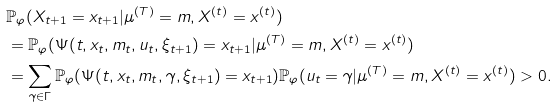Convert formula to latex. <formula><loc_0><loc_0><loc_500><loc_500>& \mathbb { P } _ { \varphi } ( X _ { t + 1 } = x _ { t + 1 } | \mu ^ { ( T ) } = m , X ^ { ( t ) } = x ^ { ( t ) } ) \\ & = \mathbb { P } _ { \varphi } ( \Psi ( t , x _ { t } , m _ { t } , u _ { t } , \xi _ { t + 1 } ) = x _ { t + 1 } | \mu ^ { ( T ) } = m , X ^ { ( t ) } = x ^ { ( t ) } ) \\ & = \sum _ { \gamma \in \Gamma } \mathbb { P } _ { \varphi } ( \Psi ( t , x _ { t } , m _ { t } , \gamma , \xi _ { t + 1 } ) = x _ { t + 1 } ) \mathbb { P } _ { \varphi } ( u _ { t } = \gamma | \mu ^ { ( T ) } = m , X ^ { ( t ) } = x ^ { ( t ) } ) > 0 .</formula> 